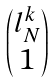<formula> <loc_0><loc_0><loc_500><loc_500>\begin{pmatrix} l _ { N } ^ { k } \\ 1 \end{pmatrix}</formula> 